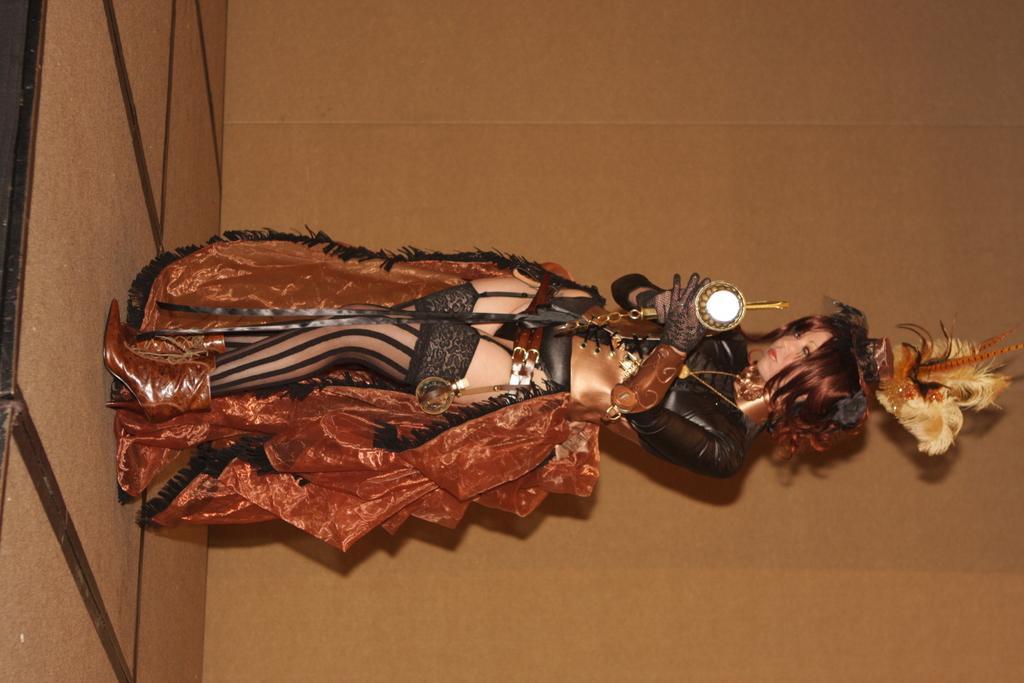Can you describe this image briefly? In this image there is one woman standing in middle of this image and holding an object. There is a wall in the background. There is a floor on the left side of this image. 